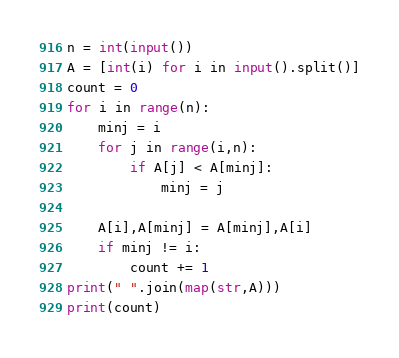Convert code to text. <code><loc_0><loc_0><loc_500><loc_500><_Python_>n = int(input())
A = [int(i) for i in input().split()]
count = 0
for i in range(n):
    minj = i
    for j in range(i,n):
        if A[j] < A[minj]:
            minj = j
            
    A[i],A[minj] = A[minj],A[i]
    if minj != i:
        count += 1
print(" ".join(map(str,A)))
print(count)
</code> 